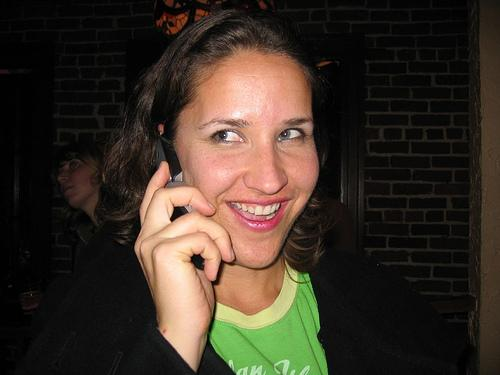Which hand is she using to hold the phone? right 